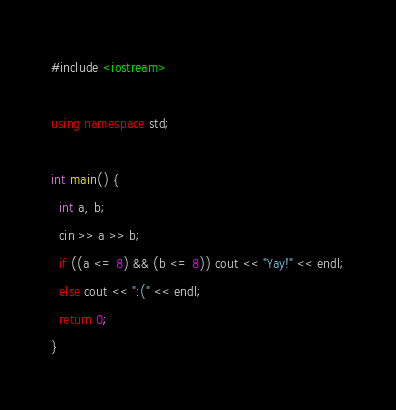Convert code to text. <code><loc_0><loc_0><loc_500><loc_500><_C++_>#include <iostream>

using namespace std;

int main() {
  int a, b;
  cin >> a >> b;
  if ((a <= 8) && (b <= 8)) cout << "Yay!" << endl;
  else cout << ":(" << endl;
  return 0;
}
</code> 